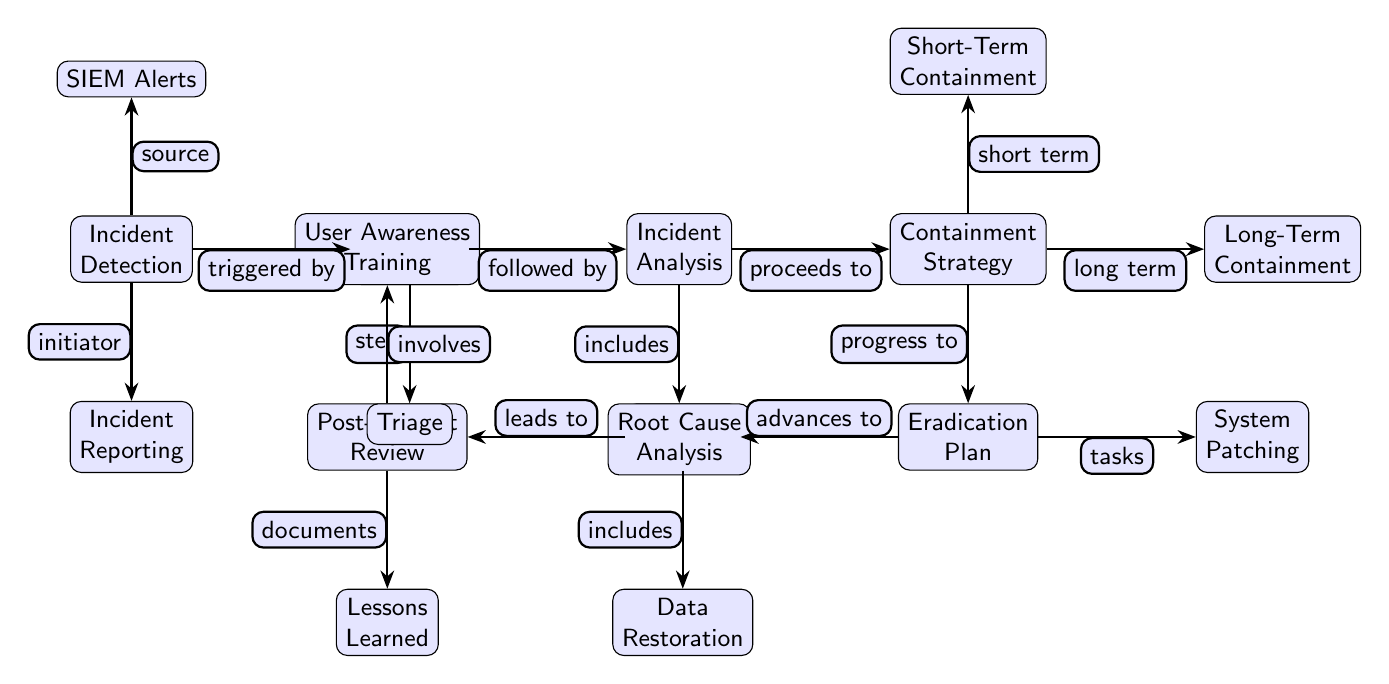What is the first step in the incident response plan? The diagram clearly lists "Incident Detection" as the first node in the sequence of steps, indicating that it's the initial action to identify security threats.
Answer: Incident Detection How many main process nodes are in the diagram? Counting the main process nodes (Incident Detection, Initial Response, Incident Analysis, Containment Strategy, Eradication Plan, Recovery Actions, Post-Incident Review), there are a total of seven main process nodes.
Answer: 7 What process follows the "Initial Response"? The diagram shows an arrow from "Initial Response" to "Incident Analysis," indicating that this is the next step in the sequence following the initial response to an incident.
Answer: Incident Analysis What triggers the Initial Response? The arrow pointing from "Incident Detection" to "Initial Response" is labeled "triggered by," which explains the cause of the initial response action.
Answer: Incident Detection What two types of containment strategies are identified? The diagram lists "Short-Term Containment" and "Long-Term Containment" as two distinct nodes under "Containment Strategy," which represent the various approaches for handling an incident's impact.
Answer: Short-Term Containment, Long-Term Containment What is the final action in the incident response plan? The last node in the series, connected from "Recovery Actions," is "Post-Incident Review," thus representing the last action to be taken after recovering from an incident.
Answer: Post-Incident Review What is conducted after the "Incident Analysis"? The flow from "Incident Analysis" to "Containment Strategy" indicates that the next step to take after analyzing an incident is to develop a containment strategy.
Answer: Containment Strategy What is included in the "Eradication Plan"? The "Eradication Plan" node connects to "System Patching," indicating that part of the eradication plan involves applying patches to the system to eliminate threats.
Answer: System Patching 